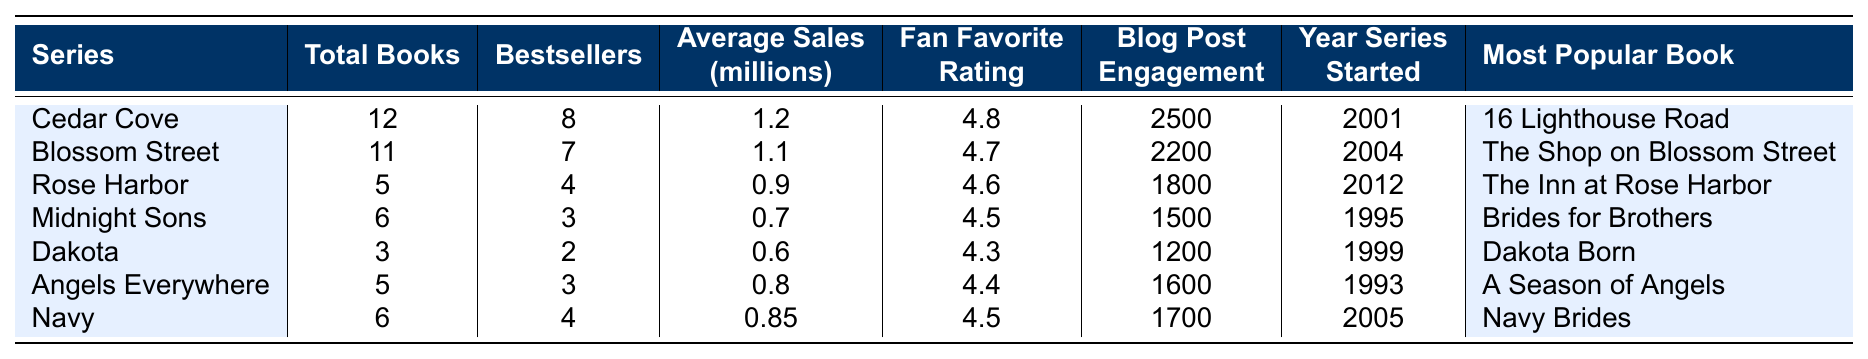What is the total number of books in the Cedar Cove series? The table lists 12 books under the Cedar Cove series in the "Total Books" column.
Answer: 12 Which series has the highest average sales? Looking at the "Average Sales (millions)" column, Cedar Cove has the highest value at 1.2 million.
Answer: Cedar Cove How many bestsellers are there in the Blossom Street series? The "Bestsellers" column shows that there are 7 bestsellers in the Blossom Street series.
Answer: 7 Which series started first based on the year? By comparing the "Year Series Started" column, Midnight Sons started in 1995, which is the earliest.
Answer: Midnight Sons Is the average sales of the Navy series greater than 0.8 million? The average sales of the Navy series is 0.85 million, which is greater than 0.8 million.
Answer: Yes What is the fan favorite rating for the Dakota series? The table shows the fan favorite rating for the Dakota series as 4.3.
Answer: 4.3 If we consider the total number of books from all series combined, how many books are there? Adding the total books in all series: 12 + 11 + 5 + 6 + 3 + 5 + 6 = 48.
Answer: 48 Which series has the least number of bestsellers? The series with the least number of bestsellers is Dakota, with 2 bestsellers.
Answer: Dakota In terms of blog post engagement, which series was the least engaged with? The "Blog Post Engagement" column shows that Dakota has the lowest engagement at 1200.
Answer: Dakota What is the average fan favorite rating for all series? To find the average, sum the fan favorite ratings: 4.8 + 4.7 + 4.6 + 4.5 + 4.3 + 4.4 + 4.5 = 32.8, then divide by 7 (number of series): 32.8 / 7 ≈ 4.69.
Answer: Approximately 4.69 Which series has the most popular book titled "The Shop on Blossom Street"? The "Most Popular Book" column lists "The Shop on Blossom Street" for the Blossom Street series.
Answer: Blossom Street How many more total books does the Cedar Cove series have compared to the Angels Everywhere series? Cedar Cove has 12 total books, while Angels Everywhere has 5. The difference is 12 - 5 = 7.
Answer: 7 What is the best-selling series based on the number of bestsellers? Cedar Cove has the most bestsellers at 8, making it the best-selling series.
Answer: Cedar Cove 